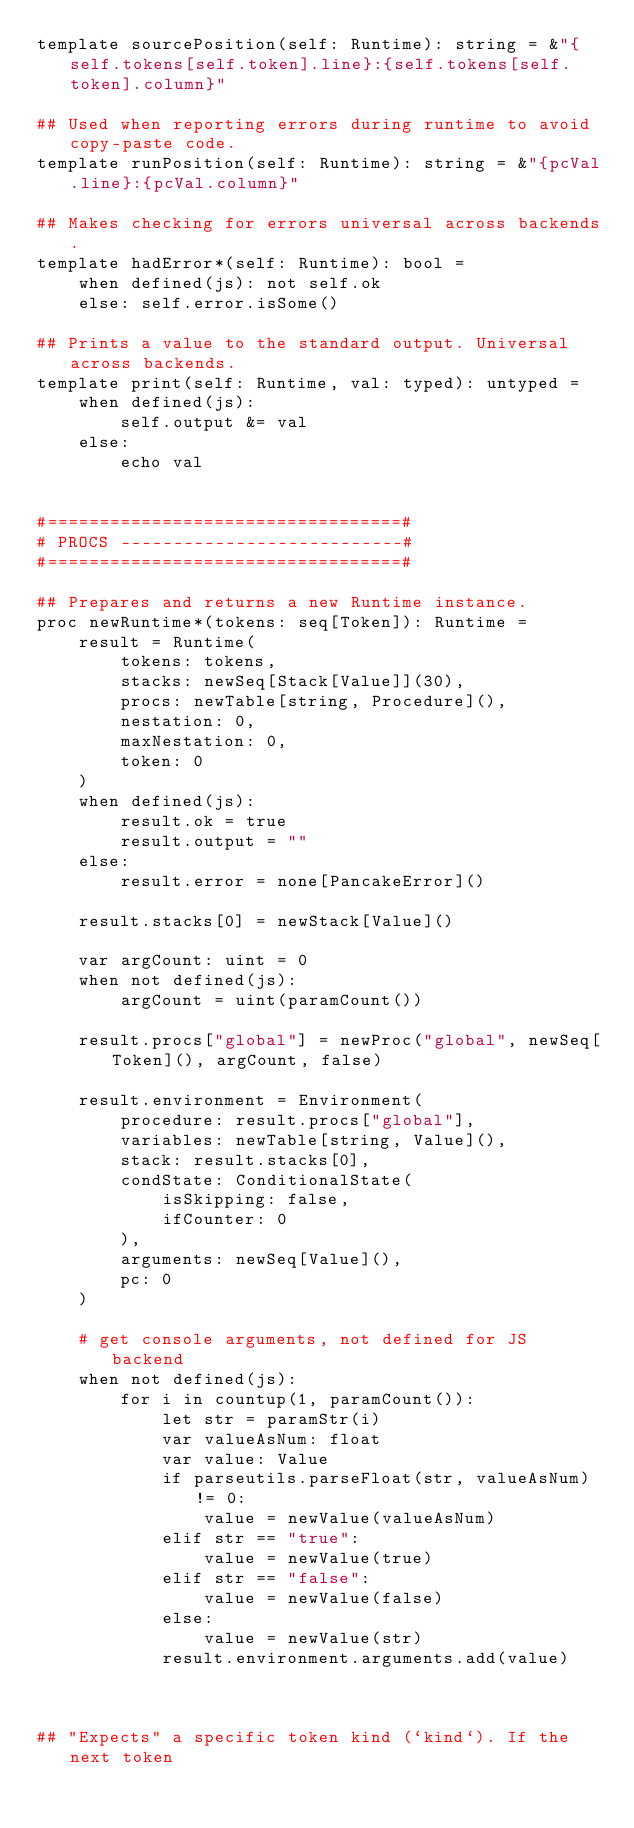<code> <loc_0><loc_0><loc_500><loc_500><_Nim_>template sourcePosition(self: Runtime): string = &"{self.tokens[self.token].line}:{self.tokens[self.token].column}"

## Used when reporting errors during runtime to avoid copy-paste code.
template runPosition(self: Runtime): string = &"{pcVal.line}:{pcVal.column}"

## Makes checking for errors universal across backends.
template hadError*(self: Runtime): bool =
    when defined(js): not self.ok
    else: self.error.isSome()

## Prints a value to the standard output. Universal across backends.
template print(self: Runtime, val: typed): untyped =
    when defined(js):
        self.output &= val
    else:
        echo val


#==================================#
# PROCS ---------------------------#
#==================================#

## Prepares and returns a new Runtime instance.
proc newRuntime*(tokens: seq[Token]): Runtime =
    result = Runtime(
        tokens: tokens,
        stacks: newSeq[Stack[Value]](30),
        procs: newTable[string, Procedure](),
        nestation: 0,
        maxNestation: 0,
        token: 0
    )
    when defined(js):
        result.ok = true
        result.output = ""
    else:
        result.error = none[PancakeError]()

    result.stacks[0] = newStack[Value]()

    var argCount: uint = 0
    when not defined(js):
        argCount = uint(paramCount())

    result.procs["global"] = newProc("global", newSeq[Token](), argCount, false)

    result.environment = Environment(
        procedure: result.procs["global"],
        variables: newTable[string, Value](),
        stack: result.stacks[0],
        condState: ConditionalState(
            isSkipping: false,
            ifCounter: 0
        ),
        arguments: newSeq[Value](),
        pc: 0
    )

    # get console arguments, not defined for JS backend
    when not defined(js):
        for i in countup(1, paramCount()):
            let str = paramStr(i)
            var valueAsNum: float
            var value: Value
            if parseutils.parseFloat(str, valueAsNum) != 0:
                value = newValue(valueAsNum)
            elif str == "true":
                value = newValue(true)
            elif str == "false":
                value = newValue(false)
            else:
                value = newValue(str)
            result.environment.arguments.add(value)



## "Expects" a specific token kind (`kind`). If the next token</code> 